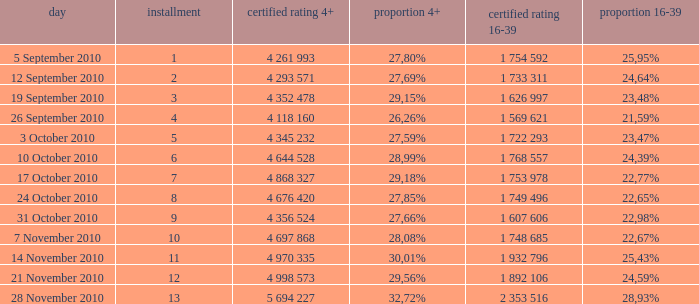What is the official rating 16-39 for the episode with  a 16-39 share of 22,77%? 1 753 978. 